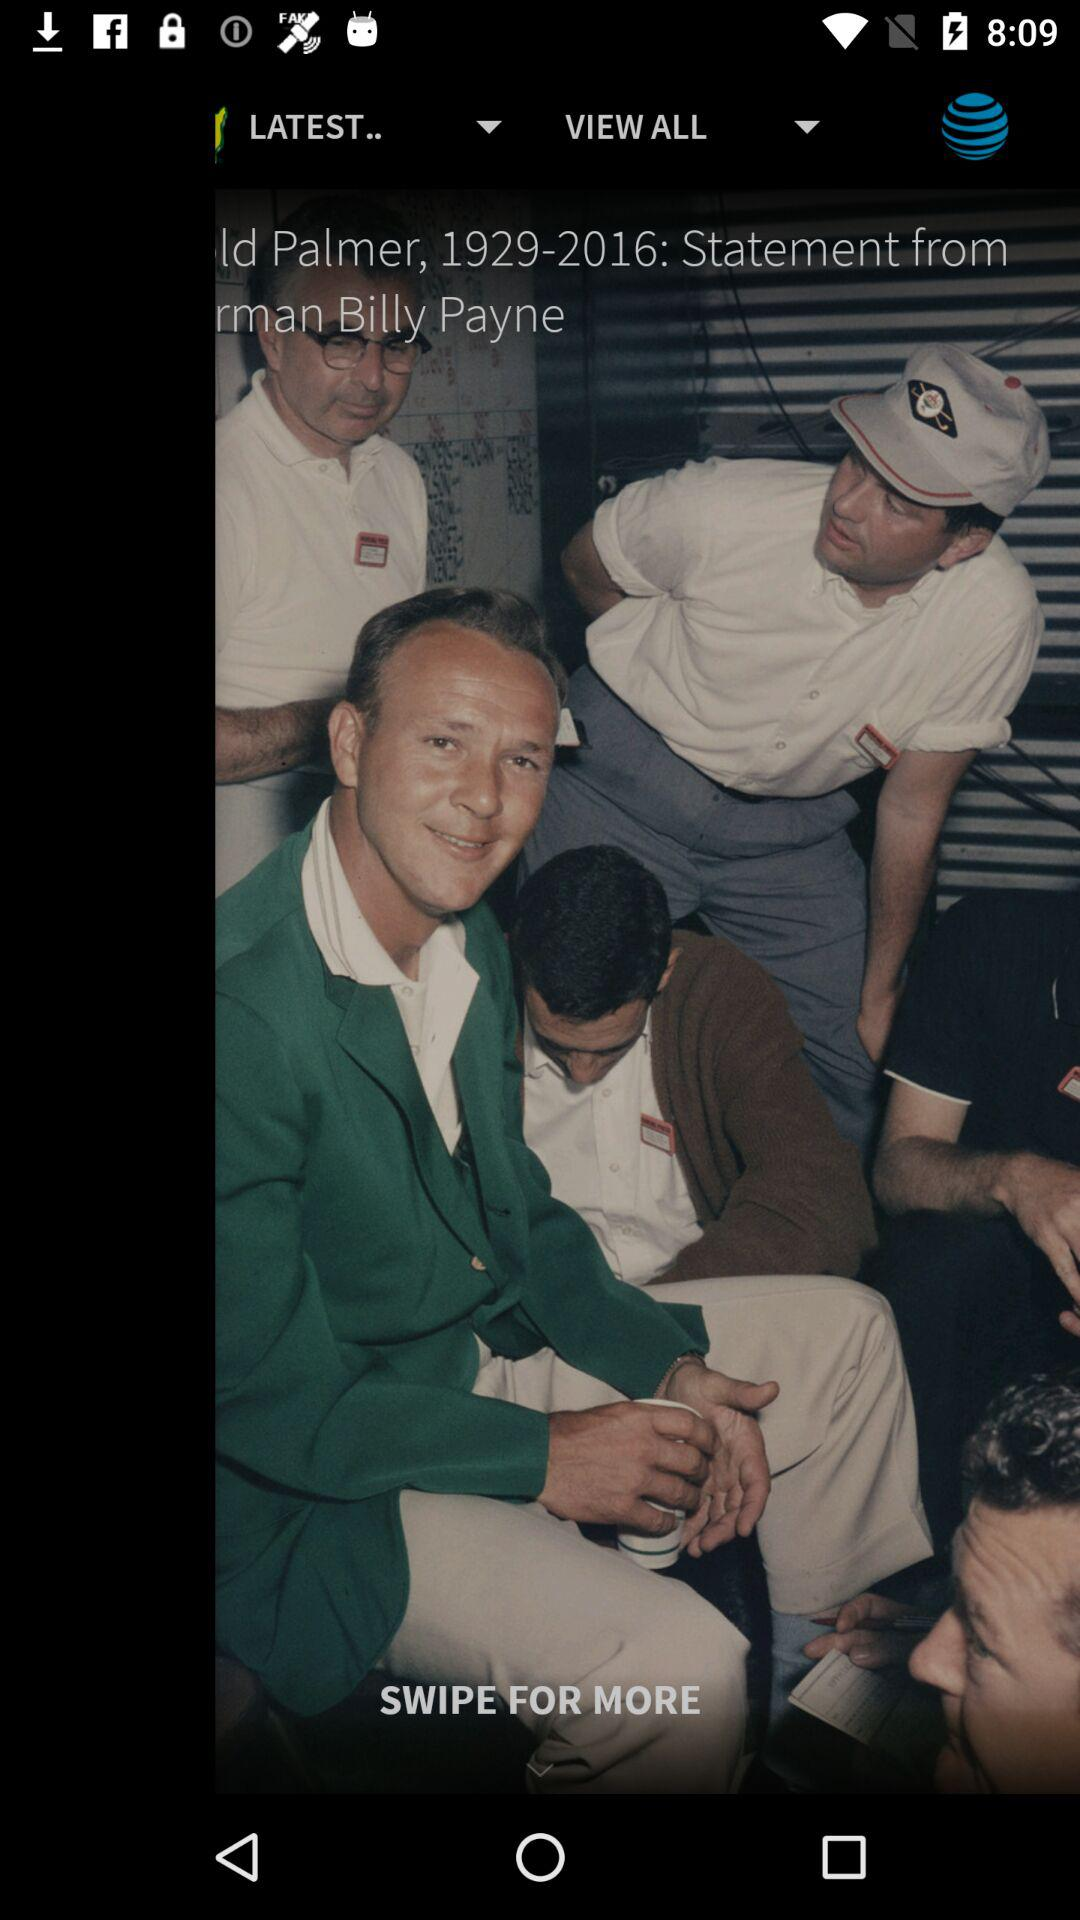What is the number of rounds? The number of rounds is 4. 